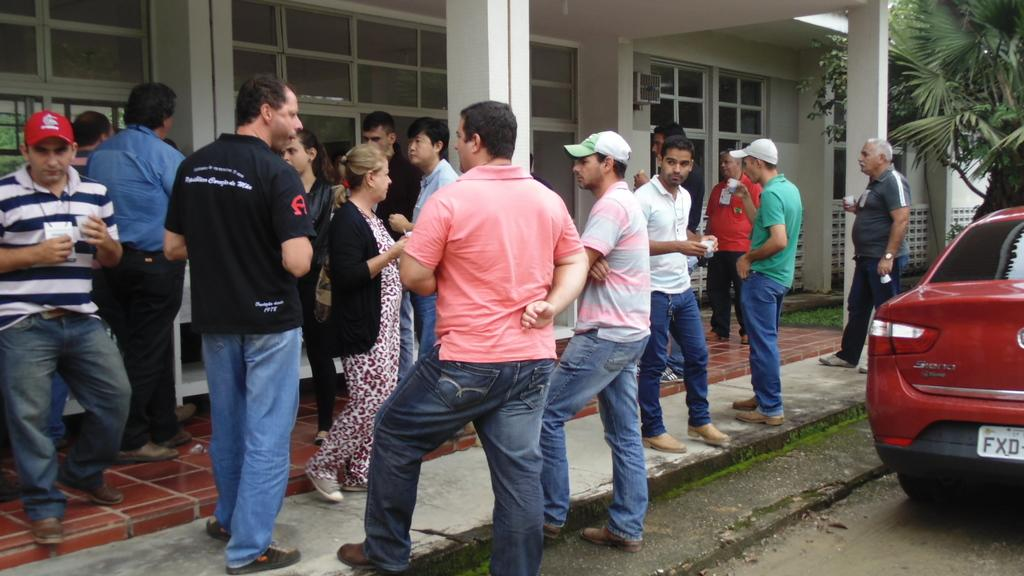What types of people are in the image? There are men and women in the image. What is the background of the image? They are standing in front of a white building. What can be seen on the right side of the image? There is a car and trees visible on the right side of the image. What type of shock can be seen affecting the window in the image? There is no window present in the image, and therefore no shock can be observed. 